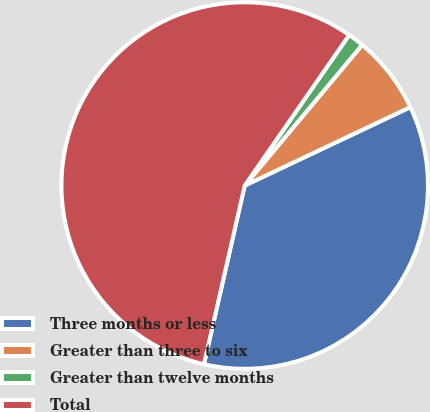Convert chart to OTSL. <chart><loc_0><loc_0><loc_500><loc_500><pie_chart><fcel>Three months or less<fcel>Greater than three to six<fcel>Greater than twelve months<fcel>Total<nl><fcel>35.61%<fcel>6.89%<fcel>1.42%<fcel>56.09%<nl></chart> 